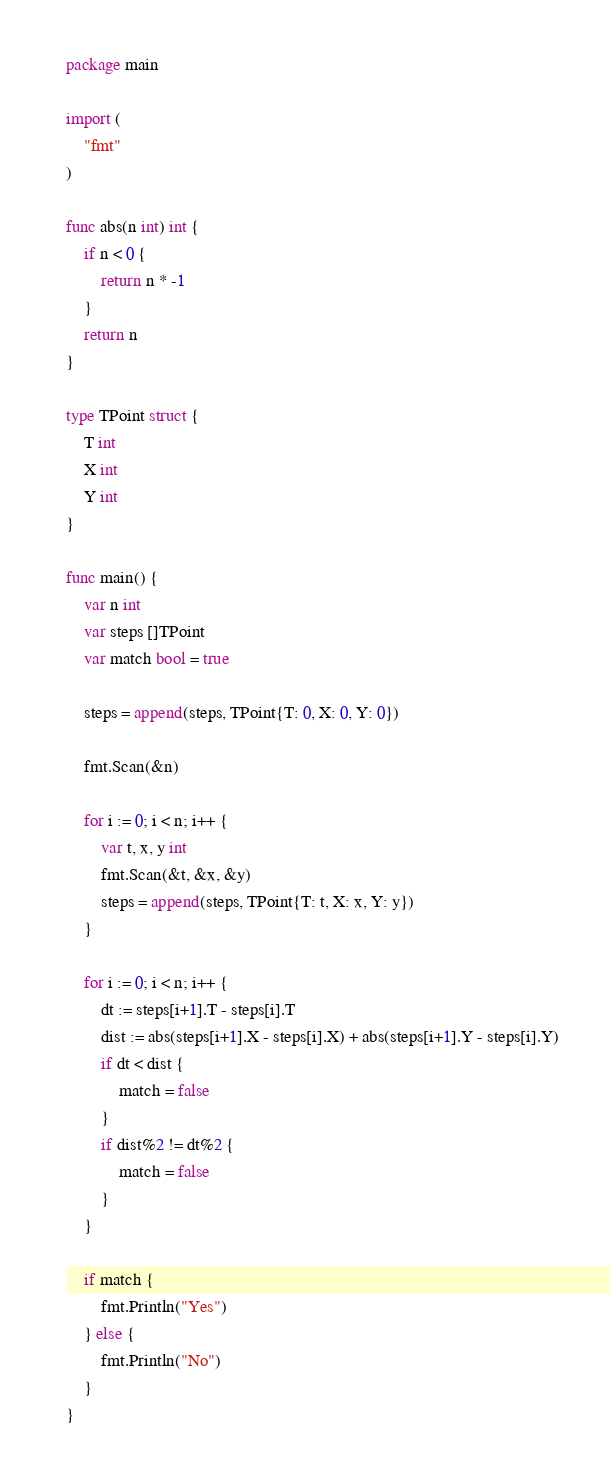Convert code to text. <code><loc_0><loc_0><loc_500><loc_500><_Go_>package main

import (
	"fmt"
)

func abs(n int) int {
	if n < 0 {
		return n * -1
	}
	return n
}

type TPoint struct {
	T int
	X int
	Y int
}

func main() {
	var n int
	var steps []TPoint
	var match bool = true

	steps = append(steps, TPoint{T: 0, X: 0, Y: 0})

	fmt.Scan(&n)

	for i := 0; i < n; i++ {
		var t, x, y int
		fmt.Scan(&t, &x, &y)
		steps = append(steps, TPoint{T: t, X: x, Y: y})
	}

	for i := 0; i < n; i++ {
		dt := steps[i+1].T - steps[i].T
		dist := abs(steps[i+1].X - steps[i].X) + abs(steps[i+1].Y - steps[i].Y)
		if dt < dist {
			match = false
		}
		if dist%2 != dt%2 {
			match = false
		}
	}

	if match {
		fmt.Println("Yes")
	} else {
		fmt.Println("No")
	}
}</code> 